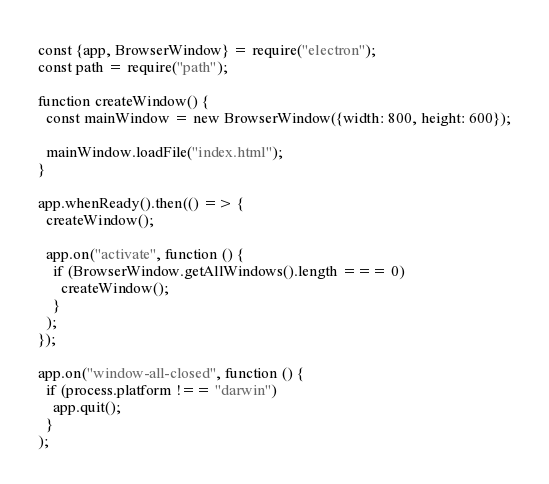Convert code to text. <code><loc_0><loc_0><loc_500><loc_500><_JavaScript_>
const {app, BrowserWindow} = require("electron");
const path = require("path");

function createWindow() {
  const mainWindow = new BrowserWindow({width: 800, height: 600});

  mainWindow.loadFile("index.html");
}

app.whenReady().then(() => {
  createWindow();

  app.on("activate", function () {
    if (BrowserWindow.getAllWindows().length === 0) 
      createWindow();
    }
  );
});

app.on("window-all-closed", function () {
  if (process.platform !== "darwin") 
    app.quit();
  }
);
</code> 